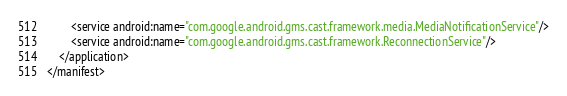Convert code to text. <code><loc_0><loc_0><loc_500><loc_500><_XML_>        <service android:name="com.google.android.gms.cast.framework.media.MediaNotificationService"/>
        <service android:name="com.google.android.gms.cast.framework.ReconnectionService"/>
    </application>
</manifest>
</code> 